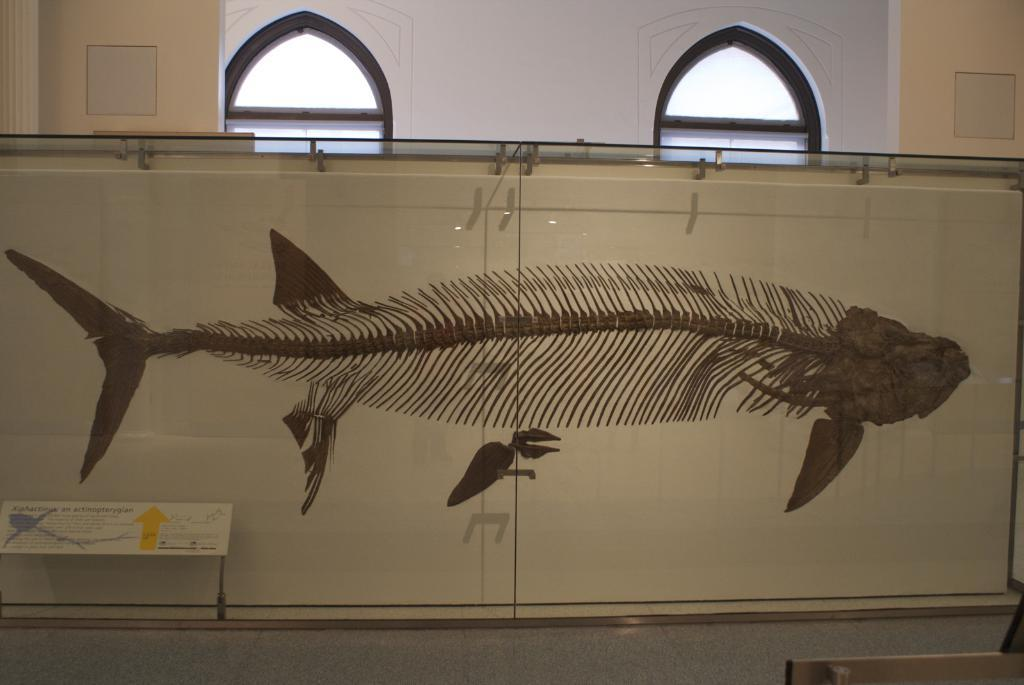What is the main subject inside the box in the image? There is a structure of a fish inside a box in the image. What else can be seen in the image besides the fish? There is a board with text in the image. What can be observed in the background of the image? There is a wall with windows and pillars visible in the background of the image. What type of lamp is hanging from the ceiling in the image? There is no lamp visible in the image; it only features a structure of a fish, a board with text, and a wall with windows and pillars in the background. 